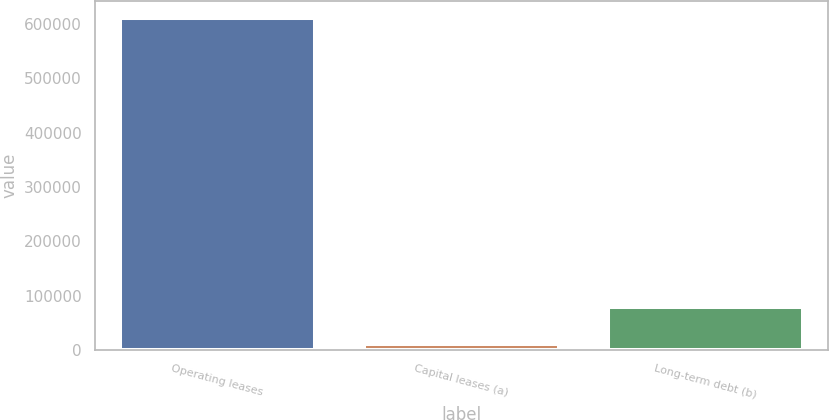<chart> <loc_0><loc_0><loc_500><loc_500><bar_chart><fcel>Operating leases<fcel>Capital leases (a)<fcel>Long-term debt (b)<nl><fcel>611835<fcel>10449<fcel>78280<nl></chart> 